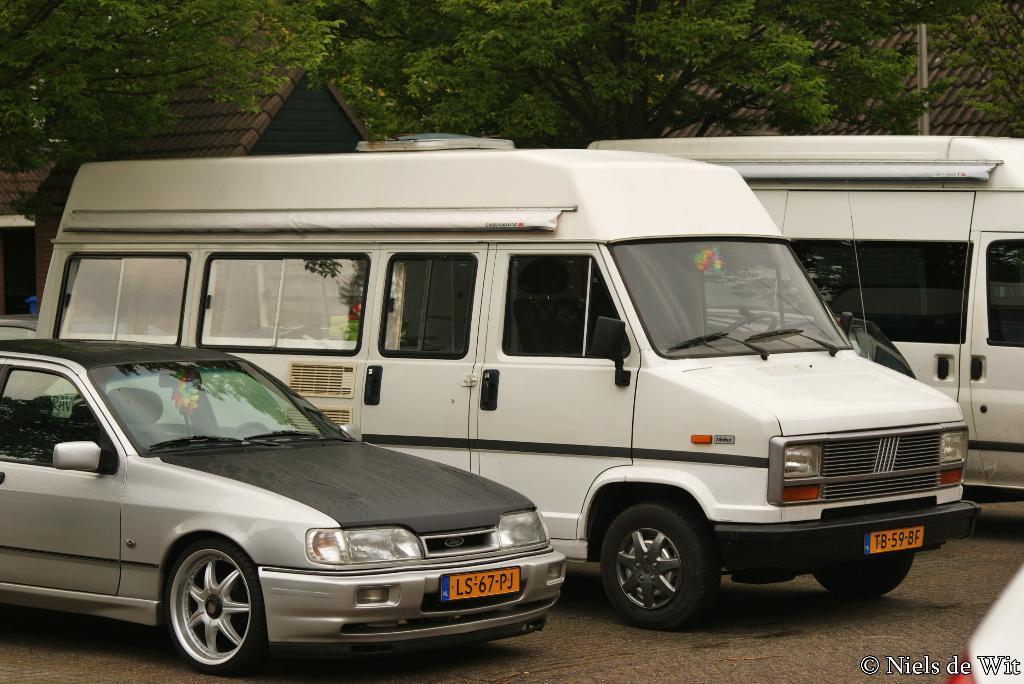What is the plate number of the car?
Your response must be concise. Ls67pj. Who holds the copyright to this photograph?
Ensure brevity in your answer.  Niels de wit. 